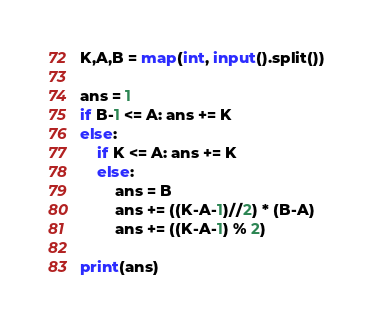<code> <loc_0><loc_0><loc_500><loc_500><_Python_>K,A,B = map(int, input().split())

ans = 1
if B-1 <= A: ans += K
else:
    if K <= A: ans += K
    else:
        ans = B
        ans += ((K-A-1)//2) * (B-A)
        ans += ((K-A-1) % 2)

print(ans)</code> 